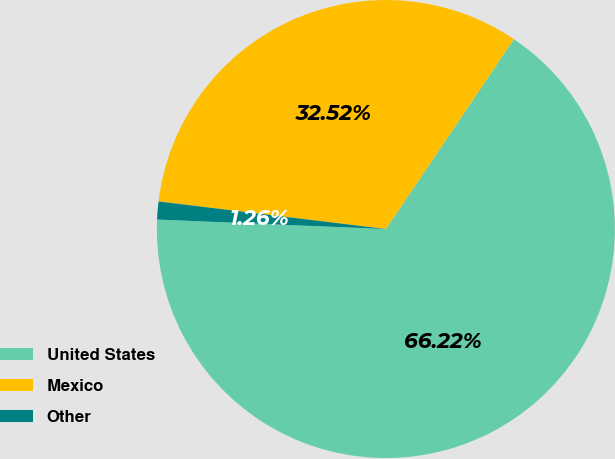<chart> <loc_0><loc_0><loc_500><loc_500><pie_chart><fcel>United States<fcel>Mexico<fcel>Other<nl><fcel>66.22%<fcel>32.52%<fcel>1.26%<nl></chart> 